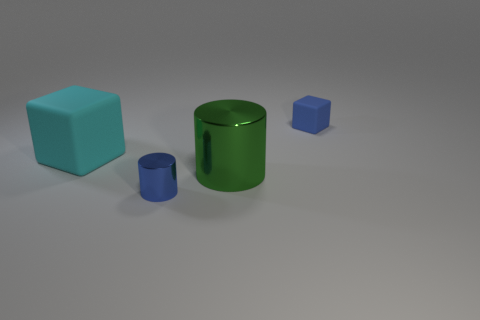Add 4 brown rubber cubes. How many objects exist? 8 Add 1 cylinders. How many cylinders are left? 3 Add 3 matte objects. How many matte objects exist? 5 Subtract 0 brown cylinders. How many objects are left? 4 Subtract all small gray metallic cubes. Subtract all large matte things. How many objects are left? 3 